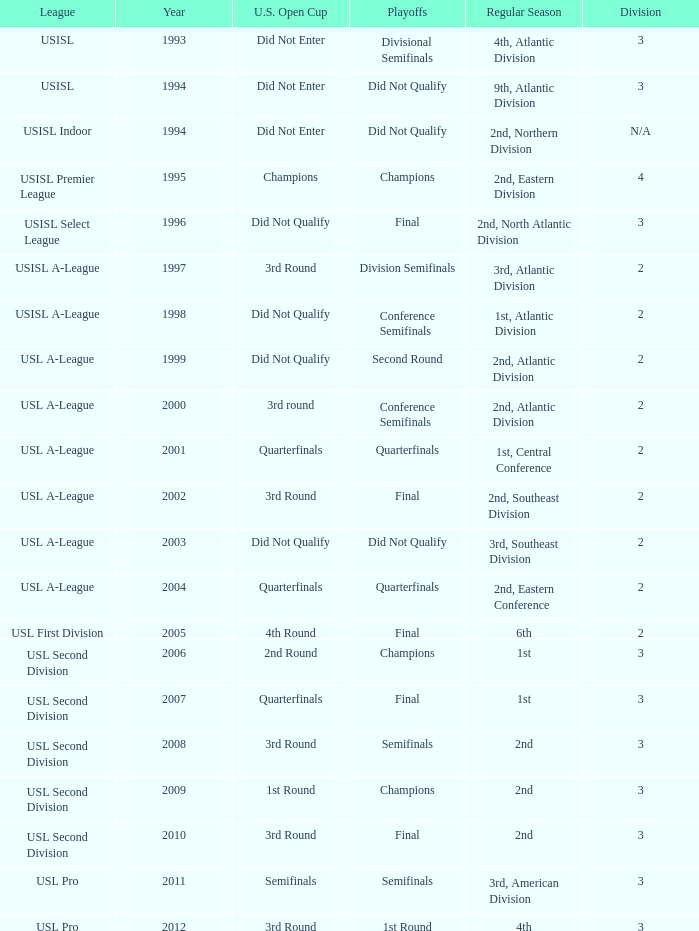How many division  did not qualify for u.s. open cup in 2003 2.0. 